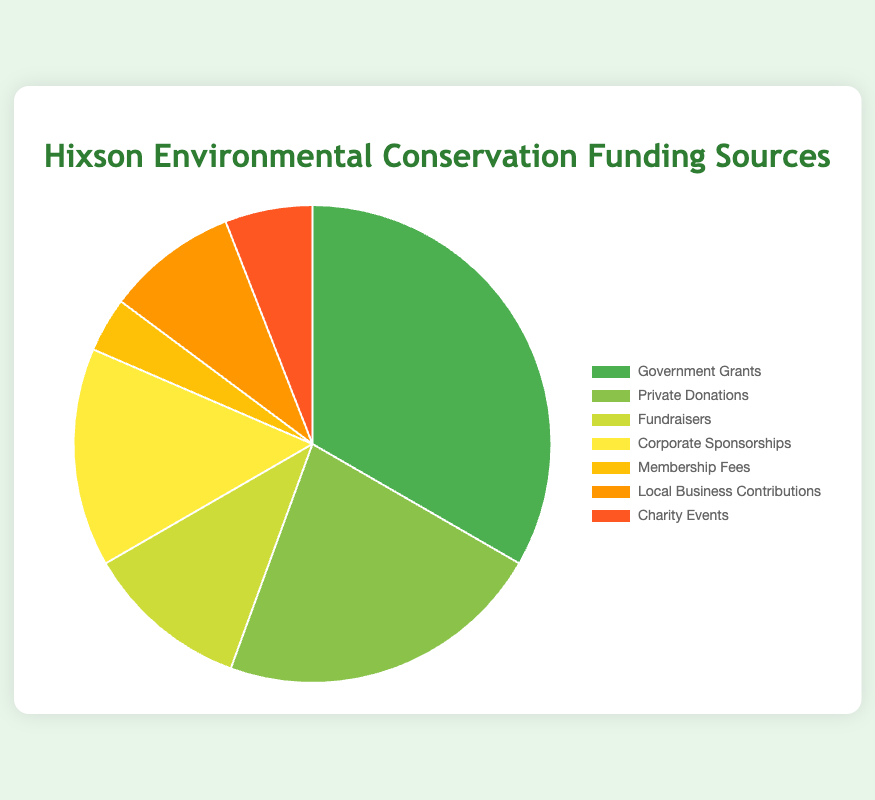What percentage of the total funding is provided by Government Grants? First, identify the amount from Government Grants ($45,000). Next, add up all the funding sources: 45000 + 30000 + 15000 + 20000 + 5000 + 12000 + 8000 = 135000. Finally, calculate the percentage: (45000 / 135000) * 100 = 33.33%
Answer: 33.33% How does the amount from Private Donations compare to that from Corporate Sponsorships? Private Donations amount to $30,000 while Corporate Sponsorships amount to $20,000. Comparing these, Private Donations are greater by $10,000.
Answer: Greater by $10,000 Which funding source has the smallest contribution, and what is its percentage of the total? The smallest contribution is from Membership Fees, which is $5,000. Total funding is $135,000. The percentage is calculated as (5000 / 135000) * 100 = 3.70%.
Answer: Membership Fees, 3.70% What is the total amount contributed by Local Business Contributions and Charity Events combined? Local Business Contributions amount to $12,000 and Charity Events contribute $8,000. Summing these values gives 12000 + 8000 = $20,000.
Answer: $20,000 How many sources contribute less than $10,000, and what are they? From the chart, the sources contributing less than $10,000 are Membership Fees ($5,000) and Charity Events ($8,000), totaling two sources.
Answer: Two sources: Membership Fees, Charity Events What is the combined percentage of funding from Fundraisers, Corporate Sponsorships, and Local Business Contributions? First, sum up the amounts from Fundraisers ($15,000), Corporate Sponsorships ($20,000), and Local Business Contributions ($12,000): 15000 + 20000 + 12000 = $47,000. Next, calculate the percentage of the total funding ($135,000): (47000 / 135000) * 100 ≈ 34.81%.
Answer: 34.81% What percentage of the total funding comes from sources other than Government Grants and Private Donations? Government Grants and Private Donations amount to $45,000 and $30,000 respectively, summing to $75,000. Total funding is $135,000. Subtracting these two gives 135000 - 75000 = $60,000. Calculate the percentage: (60000 / 135000) * 100 ≈ 44.44%.
Answer: 44.44% If the amount from Corporate Sponsorships were increased by $10,000, what would be its new percentage of the total funding? First, calculate the new amount from Corporate Sponsorships: 20000 + 10000 = $30,000. New total funding would be 135000 + 10000 = $145,000. The new percentage is (30000 / 145000) * 100 ≈ 20.69%.
Answer: 20.69% Which source contributes more: Fundraisers or Local Business Contributions, and by how much? The amount from Fundraisers is $15,000 while Local Business Contributions total $12,000. Calculating the difference: 15000 - 12000 = $3,000.
Answer: Fundraisers by $3,000 If all contributions were increased by 10%, what would be the new total funding? First, calculate 10% of the total funding: 0.10 * 135000 = $13,500. Adding this to the original total gives 135000 + 13500 = $148,500.
Answer: $148,500 